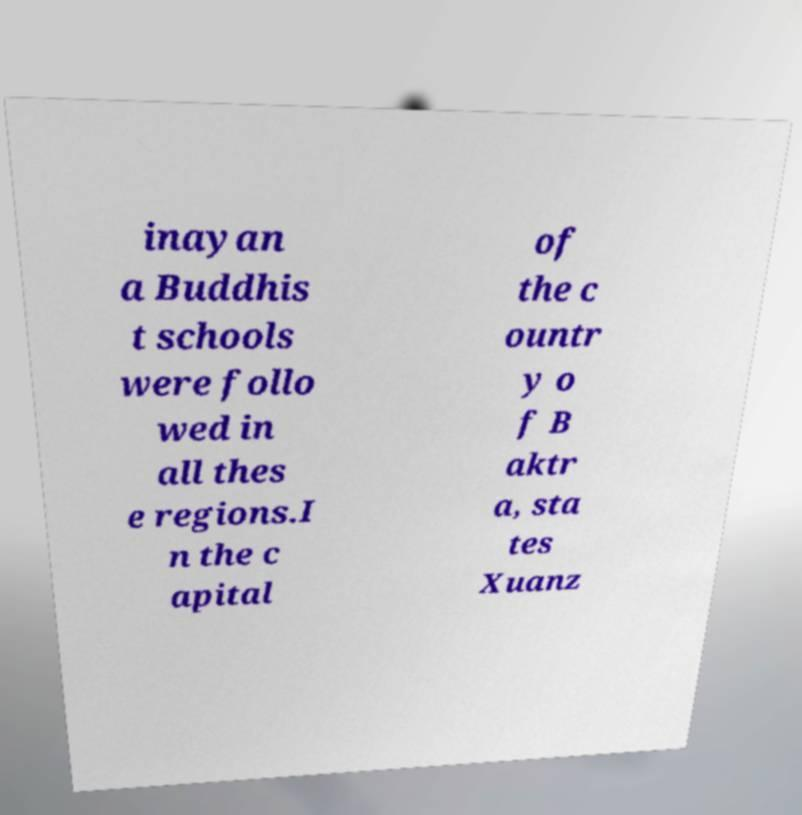Could you assist in decoding the text presented in this image and type it out clearly? inayan a Buddhis t schools were follo wed in all thes e regions.I n the c apital of the c ountr y o f B aktr a, sta tes Xuanz 